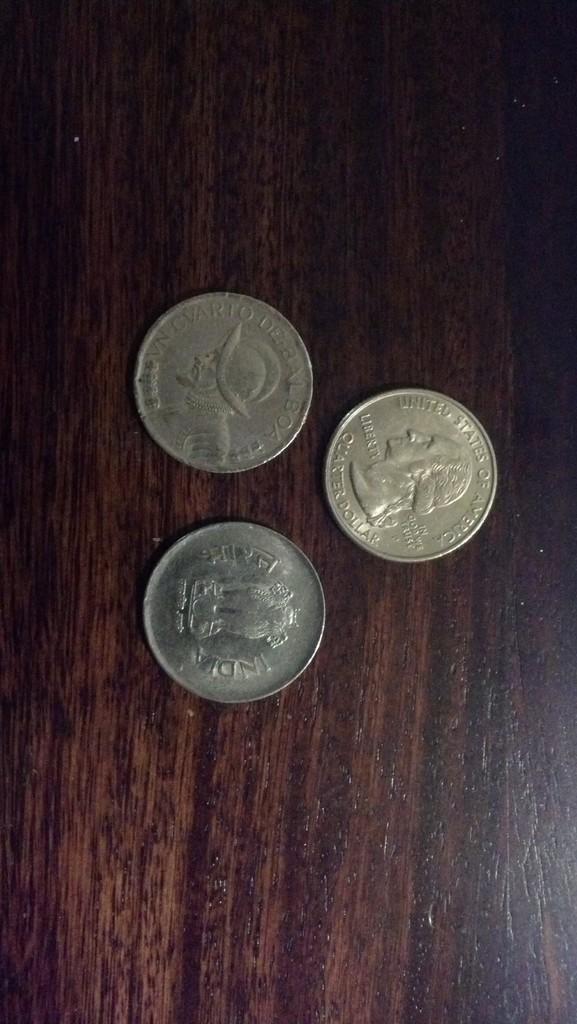What country is the coin in the middle from?
Ensure brevity in your answer.  United states of america. 